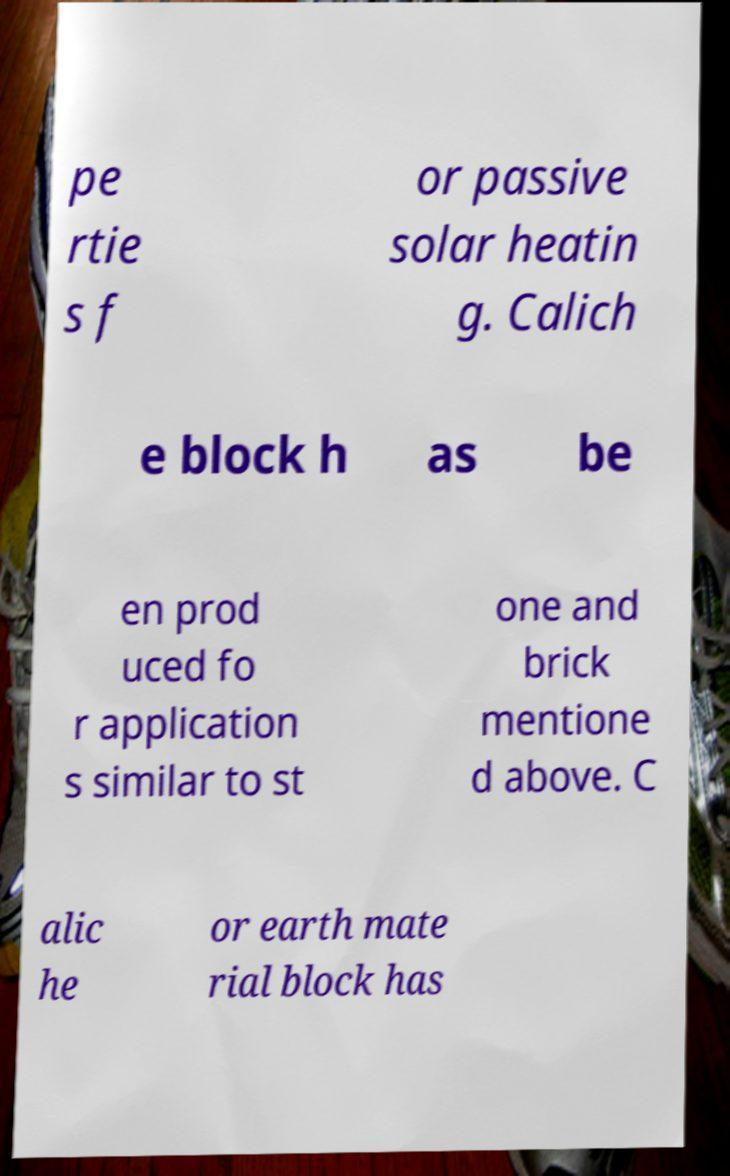There's text embedded in this image that I need extracted. Can you transcribe it verbatim? pe rtie s f or passive solar heatin g. Calich e block h as be en prod uced fo r application s similar to st one and brick mentione d above. C alic he or earth mate rial block has 